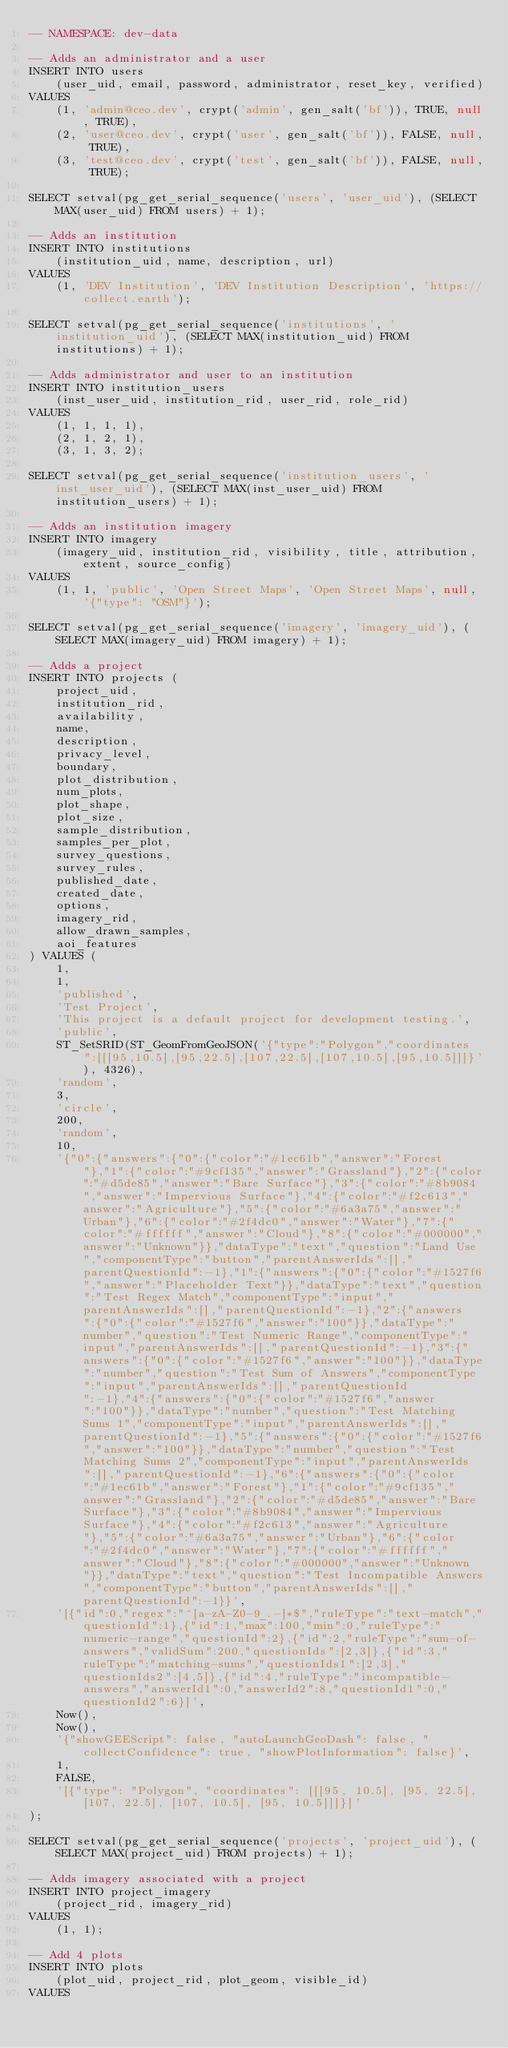Convert code to text. <code><loc_0><loc_0><loc_500><loc_500><_SQL_>-- NAMESPACE: dev-data

-- Adds an administrator and a user
INSERT INTO users
    (user_uid, email, password, administrator, reset_key, verified)
VALUES
    (1, 'admin@ceo.dev', crypt('admin', gen_salt('bf')), TRUE, null, TRUE),
    (2, 'user@ceo.dev', crypt('user', gen_salt('bf')), FALSE, null, TRUE),
    (3, 'test@ceo.dev', crypt('test', gen_salt('bf')), FALSE, null, TRUE);

SELECT setval(pg_get_serial_sequence('users', 'user_uid'), (SELECT MAX(user_uid) FROM users) + 1);

-- Adds an institution
INSERT INTO institutions
    (institution_uid, name, description, url)
VALUES
    (1, 'DEV Institution', 'DEV Institution Description', 'https://collect.earth');

SELECT setval(pg_get_serial_sequence('institutions', 'institution_uid'), (SELECT MAX(institution_uid) FROM institutions) + 1);

-- Adds administrator and user to an institution
INSERT INTO institution_users
    (inst_user_uid, institution_rid, user_rid, role_rid)
VALUES
    (1, 1, 1, 1),
    (2, 1, 2, 1),
    (3, 1, 3, 2);

SELECT setval(pg_get_serial_sequence('institution_users', 'inst_user_uid'), (SELECT MAX(inst_user_uid) FROM institution_users) + 1);

-- Adds an institution imagery
INSERT INTO imagery
    (imagery_uid, institution_rid, visibility, title, attribution, extent, source_config)
VALUES
    (1, 1, 'public', 'Open Street Maps', 'Open Street Maps', null, '{"type": "OSM"}');

SELECT setval(pg_get_serial_sequence('imagery', 'imagery_uid'), (SELECT MAX(imagery_uid) FROM imagery) + 1);

-- Adds a project
INSERT INTO projects (
    project_uid,
    institution_rid,
    availability,
    name,
    description,
    privacy_level,
    boundary,
    plot_distribution,
    num_plots,
    plot_shape,
    plot_size,
    sample_distribution,
    samples_per_plot,
    survey_questions,
    survey_rules,
    published_date,
    created_date,
    options,
    imagery_rid,
    allow_drawn_samples,
    aoi_features
) VALUES (
    1,
    1,
    'published',
    'Test Project',
    'This project is a default project for development testing.',
    'public',
    ST_SetSRID(ST_GeomFromGeoJSON('{"type":"Polygon","coordinates":[[[95,10.5],[95,22.5],[107,22.5],[107,10.5],[95,10.5]]]}'), 4326),
    'random',
    3,
    'circle',
    200,
    'random',
    10,
    '{"0":{"answers":{"0":{"color":"#1ec61b","answer":"Forest"},"1":{"color":"#9cf135","answer":"Grassland"},"2":{"color":"#d5de85","answer":"Bare Surface"},"3":{"color":"#8b9084","answer":"Impervious Surface"},"4":{"color":"#f2c613","answer":"Agriculture"},"5":{"color":"#6a3a75","answer":"Urban"},"6":{"color":"#2f4dc0","answer":"Water"},"7":{"color":"#ffffff","answer":"Cloud"},"8":{"color":"#000000","answer":"Unknown"}},"dataType":"text","question":"Land Use","componentType":"button","parentAnswerIds":[],"parentQuestionId":-1},"1":{"answers":{"0":{"color":"#1527f6","answer":"Placeholder Text"}},"dataType":"text","question":"Test Regex Match","componentType":"input","parentAnswerIds":[],"parentQuestionId":-1},"2":{"answers":{"0":{"color":"#1527f6","answer":"100"}},"dataType":"number","question":"Test Numeric Range","componentType":"input","parentAnswerIds":[],"parentQuestionId":-1},"3":{"answers":{"0":{"color":"#1527f6","answer":"100"}},"dataType":"number","question":"Test Sum of Answers","componentType":"input","parentAnswerIds":[],"parentQuestionId":-1},"4":{"answers":{"0":{"color":"#1527f6","answer":"100"}},"dataType":"number","question":"Test Matching Sums 1","componentType":"input","parentAnswerIds":[],"parentQuestionId":-1},"5":{"answers":{"0":{"color":"#1527f6","answer":"100"}},"dataType":"number","question":"Test Matching Sums 2","componentType":"input","parentAnswerIds":[],"parentQuestionId":-1},"6":{"answers":{"0":{"color":"#1ec61b","answer":"Forest"},"1":{"color":"#9cf135","answer":"Grassland"},"2":{"color":"#d5de85","answer":"Bare Surface"},"3":{"color":"#8b9084","answer":"Impervious Surface"},"4":{"color":"#f2c613","answer":"Agriculture"},"5":{"color":"#6a3a75","answer":"Urban"},"6":{"color":"#2f4dc0","answer":"Water"},"7":{"color":"#ffffff","answer":"Cloud"},"8":{"color":"#000000","answer":"Unknown"}},"dataType":"text","question":"Test Incompatible Answers","componentType":"button","parentAnswerIds":[],"parentQuestionId":-1}}',
    '[{"id":0,"regex":"^[a-zA-Z0-9_.-]*$","ruleType":"text-match","questionId":1},{"id":1,"max":100,"min":0,"ruleType":"numeric-range","questionId":2},{"id":2,"ruleType":"sum-of-answers","validSum":200,"questionIds":[2,3]},{"id":3,"ruleType":"matching-sums","questionIds1":[2,3],"questionIds2":[4,5]},{"id":4,"ruleType":"incompatible-answers","answerId1":0,"answerId2":8,"questionId1":0,"questionId2":6}]',
    Now(),
    Now(),
    '{"showGEEScript": false, "autoLaunchGeoDash": false, "collectConfidence": true, "showPlotInformation": false}',
    1,
    FALSE,
    '[{"type": "Polygon", "coordinates": [[[95, 10.5], [95, 22.5], [107, 22.5], [107, 10.5], [95, 10.5]]]}]'
);

SELECT setval(pg_get_serial_sequence('projects', 'project_uid'), (SELECT MAX(project_uid) FROM projects) + 1);

-- Adds imagery associated with a project
INSERT INTO project_imagery
    (project_rid, imagery_rid)
VALUES
    (1, 1);

-- Add 4 plots
INSERT INTO plots
    (plot_uid, project_rid, plot_geom, visible_id)
VALUES</code> 